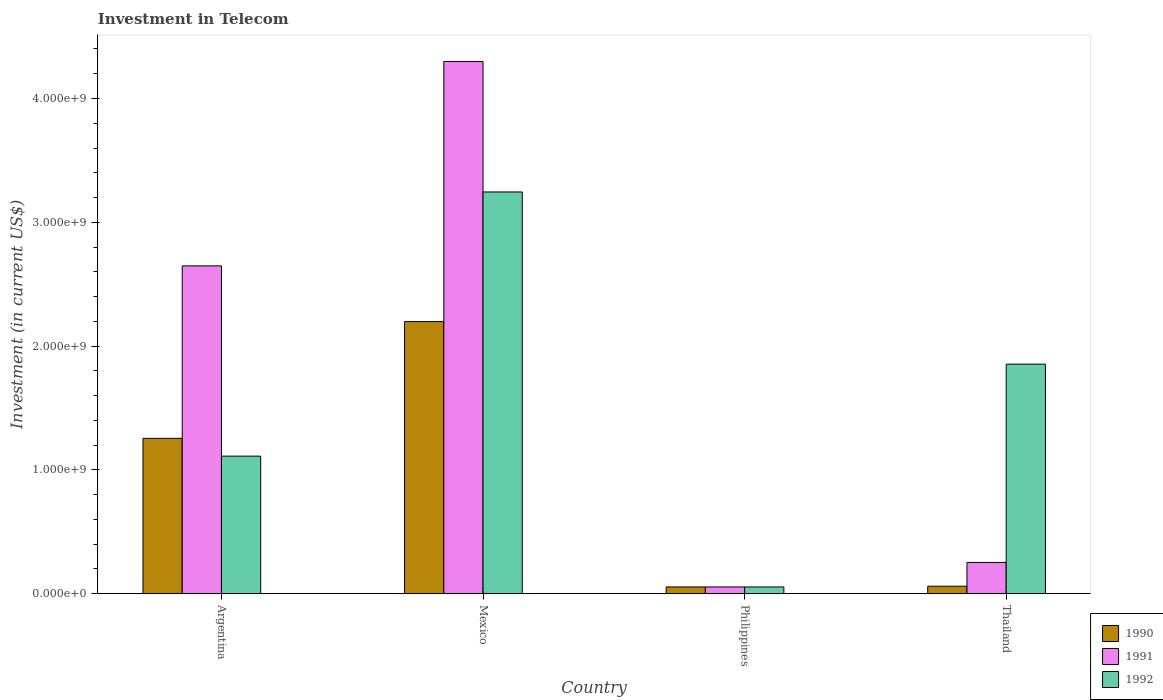How many bars are there on the 4th tick from the left?
Offer a very short reply. 3. How many bars are there on the 3rd tick from the right?
Offer a terse response. 3. What is the amount invested in telecom in 1990 in Philippines?
Offer a terse response. 5.42e+07. Across all countries, what is the maximum amount invested in telecom in 1992?
Offer a terse response. 3.24e+09. Across all countries, what is the minimum amount invested in telecom in 1992?
Give a very brief answer. 5.42e+07. What is the total amount invested in telecom in 1990 in the graph?
Keep it short and to the point. 3.57e+09. What is the difference between the amount invested in telecom in 1992 in Argentina and that in Philippines?
Ensure brevity in your answer.  1.06e+09. What is the difference between the amount invested in telecom in 1991 in Thailand and the amount invested in telecom in 1992 in Argentina?
Provide a short and direct response. -8.59e+08. What is the average amount invested in telecom in 1991 per country?
Give a very brief answer. 1.81e+09. What is the difference between the amount invested in telecom of/in 1991 and amount invested in telecom of/in 1990 in Mexico?
Provide a succinct answer. 2.10e+09. In how many countries, is the amount invested in telecom in 1991 greater than 2400000000 US$?
Your response must be concise. 2. What is the ratio of the amount invested in telecom in 1992 in Mexico to that in Philippines?
Ensure brevity in your answer.  59.87. Is the amount invested in telecom in 1992 in Mexico less than that in Philippines?
Give a very brief answer. No. What is the difference between the highest and the second highest amount invested in telecom in 1990?
Provide a short and direct response. 2.14e+09. What is the difference between the highest and the lowest amount invested in telecom in 1991?
Your answer should be very brief. 4.24e+09. What does the 2nd bar from the left in Thailand represents?
Make the answer very short. 1991. Is it the case that in every country, the sum of the amount invested in telecom in 1990 and amount invested in telecom in 1992 is greater than the amount invested in telecom in 1991?
Offer a terse response. No. How many bars are there?
Offer a very short reply. 12. Are all the bars in the graph horizontal?
Your answer should be compact. No. What is the difference between two consecutive major ticks on the Y-axis?
Keep it short and to the point. 1.00e+09. Are the values on the major ticks of Y-axis written in scientific E-notation?
Make the answer very short. Yes. Where does the legend appear in the graph?
Keep it short and to the point. Bottom right. How many legend labels are there?
Offer a very short reply. 3. What is the title of the graph?
Make the answer very short. Investment in Telecom. Does "2006" appear as one of the legend labels in the graph?
Give a very brief answer. No. What is the label or title of the X-axis?
Keep it short and to the point. Country. What is the label or title of the Y-axis?
Give a very brief answer. Investment (in current US$). What is the Investment (in current US$) in 1990 in Argentina?
Offer a terse response. 1.25e+09. What is the Investment (in current US$) of 1991 in Argentina?
Make the answer very short. 2.65e+09. What is the Investment (in current US$) of 1992 in Argentina?
Your answer should be compact. 1.11e+09. What is the Investment (in current US$) in 1990 in Mexico?
Give a very brief answer. 2.20e+09. What is the Investment (in current US$) in 1991 in Mexico?
Give a very brief answer. 4.30e+09. What is the Investment (in current US$) of 1992 in Mexico?
Offer a very short reply. 3.24e+09. What is the Investment (in current US$) in 1990 in Philippines?
Make the answer very short. 5.42e+07. What is the Investment (in current US$) of 1991 in Philippines?
Your response must be concise. 5.42e+07. What is the Investment (in current US$) in 1992 in Philippines?
Your answer should be compact. 5.42e+07. What is the Investment (in current US$) of 1990 in Thailand?
Your answer should be compact. 6.00e+07. What is the Investment (in current US$) in 1991 in Thailand?
Your answer should be very brief. 2.52e+08. What is the Investment (in current US$) in 1992 in Thailand?
Keep it short and to the point. 1.85e+09. Across all countries, what is the maximum Investment (in current US$) of 1990?
Keep it short and to the point. 2.20e+09. Across all countries, what is the maximum Investment (in current US$) of 1991?
Ensure brevity in your answer.  4.30e+09. Across all countries, what is the maximum Investment (in current US$) in 1992?
Keep it short and to the point. 3.24e+09. Across all countries, what is the minimum Investment (in current US$) in 1990?
Provide a succinct answer. 5.42e+07. Across all countries, what is the minimum Investment (in current US$) in 1991?
Your response must be concise. 5.42e+07. Across all countries, what is the minimum Investment (in current US$) of 1992?
Your answer should be very brief. 5.42e+07. What is the total Investment (in current US$) of 1990 in the graph?
Give a very brief answer. 3.57e+09. What is the total Investment (in current US$) in 1991 in the graph?
Your answer should be very brief. 7.25e+09. What is the total Investment (in current US$) in 1992 in the graph?
Your answer should be compact. 6.26e+09. What is the difference between the Investment (in current US$) of 1990 in Argentina and that in Mexico?
Make the answer very short. -9.43e+08. What is the difference between the Investment (in current US$) of 1991 in Argentina and that in Mexico?
Make the answer very short. -1.65e+09. What is the difference between the Investment (in current US$) of 1992 in Argentina and that in Mexico?
Keep it short and to the point. -2.13e+09. What is the difference between the Investment (in current US$) in 1990 in Argentina and that in Philippines?
Your answer should be compact. 1.20e+09. What is the difference between the Investment (in current US$) in 1991 in Argentina and that in Philippines?
Your answer should be compact. 2.59e+09. What is the difference between the Investment (in current US$) of 1992 in Argentina and that in Philippines?
Offer a very short reply. 1.06e+09. What is the difference between the Investment (in current US$) in 1990 in Argentina and that in Thailand?
Your response must be concise. 1.19e+09. What is the difference between the Investment (in current US$) of 1991 in Argentina and that in Thailand?
Ensure brevity in your answer.  2.40e+09. What is the difference between the Investment (in current US$) in 1992 in Argentina and that in Thailand?
Provide a short and direct response. -7.43e+08. What is the difference between the Investment (in current US$) in 1990 in Mexico and that in Philippines?
Give a very brief answer. 2.14e+09. What is the difference between the Investment (in current US$) in 1991 in Mexico and that in Philippines?
Offer a terse response. 4.24e+09. What is the difference between the Investment (in current US$) in 1992 in Mexico and that in Philippines?
Give a very brief answer. 3.19e+09. What is the difference between the Investment (in current US$) in 1990 in Mexico and that in Thailand?
Give a very brief answer. 2.14e+09. What is the difference between the Investment (in current US$) in 1991 in Mexico and that in Thailand?
Offer a terse response. 4.05e+09. What is the difference between the Investment (in current US$) of 1992 in Mexico and that in Thailand?
Give a very brief answer. 1.39e+09. What is the difference between the Investment (in current US$) in 1990 in Philippines and that in Thailand?
Your answer should be very brief. -5.80e+06. What is the difference between the Investment (in current US$) in 1991 in Philippines and that in Thailand?
Your answer should be compact. -1.98e+08. What is the difference between the Investment (in current US$) of 1992 in Philippines and that in Thailand?
Provide a succinct answer. -1.80e+09. What is the difference between the Investment (in current US$) of 1990 in Argentina and the Investment (in current US$) of 1991 in Mexico?
Give a very brief answer. -3.04e+09. What is the difference between the Investment (in current US$) in 1990 in Argentina and the Investment (in current US$) in 1992 in Mexico?
Offer a very short reply. -1.99e+09. What is the difference between the Investment (in current US$) in 1991 in Argentina and the Investment (in current US$) in 1992 in Mexico?
Your answer should be very brief. -5.97e+08. What is the difference between the Investment (in current US$) of 1990 in Argentina and the Investment (in current US$) of 1991 in Philippines?
Provide a short and direct response. 1.20e+09. What is the difference between the Investment (in current US$) of 1990 in Argentina and the Investment (in current US$) of 1992 in Philippines?
Provide a succinct answer. 1.20e+09. What is the difference between the Investment (in current US$) of 1991 in Argentina and the Investment (in current US$) of 1992 in Philippines?
Give a very brief answer. 2.59e+09. What is the difference between the Investment (in current US$) of 1990 in Argentina and the Investment (in current US$) of 1991 in Thailand?
Keep it short and to the point. 1.00e+09. What is the difference between the Investment (in current US$) of 1990 in Argentina and the Investment (in current US$) of 1992 in Thailand?
Ensure brevity in your answer.  -5.99e+08. What is the difference between the Investment (in current US$) of 1991 in Argentina and the Investment (in current US$) of 1992 in Thailand?
Your answer should be very brief. 7.94e+08. What is the difference between the Investment (in current US$) in 1990 in Mexico and the Investment (in current US$) in 1991 in Philippines?
Give a very brief answer. 2.14e+09. What is the difference between the Investment (in current US$) in 1990 in Mexico and the Investment (in current US$) in 1992 in Philippines?
Offer a terse response. 2.14e+09. What is the difference between the Investment (in current US$) in 1991 in Mexico and the Investment (in current US$) in 1992 in Philippines?
Your answer should be compact. 4.24e+09. What is the difference between the Investment (in current US$) in 1990 in Mexico and the Investment (in current US$) in 1991 in Thailand?
Give a very brief answer. 1.95e+09. What is the difference between the Investment (in current US$) in 1990 in Mexico and the Investment (in current US$) in 1992 in Thailand?
Offer a terse response. 3.44e+08. What is the difference between the Investment (in current US$) of 1991 in Mexico and the Investment (in current US$) of 1992 in Thailand?
Offer a very short reply. 2.44e+09. What is the difference between the Investment (in current US$) in 1990 in Philippines and the Investment (in current US$) in 1991 in Thailand?
Ensure brevity in your answer.  -1.98e+08. What is the difference between the Investment (in current US$) in 1990 in Philippines and the Investment (in current US$) in 1992 in Thailand?
Ensure brevity in your answer.  -1.80e+09. What is the difference between the Investment (in current US$) of 1991 in Philippines and the Investment (in current US$) of 1992 in Thailand?
Your answer should be compact. -1.80e+09. What is the average Investment (in current US$) in 1990 per country?
Offer a terse response. 8.92e+08. What is the average Investment (in current US$) in 1991 per country?
Ensure brevity in your answer.  1.81e+09. What is the average Investment (in current US$) in 1992 per country?
Provide a short and direct response. 1.57e+09. What is the difference between the Investment (in current US$) in 1990 and Investment (in current US$) in 1991 in Argentina?
Offer a very short reply. -1.39e+09. What is the difference between the Investment (in current US$) in 1990 and Investment (in current US$) in 1992 in Argentina?
Provide a short and direct response. 1.44e+08. What is the difference between the Investment (in current US$) of 1991 and Investment (in current US$) of 1992 in Argentina?
Provide a succinct answer. 1.54e+09. What is the difference between the Investment (in current US$) in 1990 and Investment (in current US$) in 1991 in Mexico?
Ensure brevity in your answer.  -2.10e+09. What is the difference between the Investment (in current US$) in 1990 and Investment (in current US$) in 1992 in Mexico?
Make the answer very short. -1.05e+09. What is the difference between the Investment (in current US$) of 1991 and Investment (in current US$) of 1992 in Mexico?
Make the answer very short. 1.05e+09. What is the difference between the Investment (in current US$) of 1990 and Investment (in current US$) of 1992 in Philippines?
Keep it short and to the point. 0. What is the difference between the Investment (in current US$) in 1991 and Investment (in current US$) in 1992 in Philippines?
Offer a very short reply. 0. What is the difference between the Investment (in current US$) of 1990 and Investment (in current US$) of 1991 in Thailand?
Your answer should be compact. -1.92e+08. What is the difference between the Investment (in current US$) in 1990 and Investment (in current US$) in 1992 in Thailand?
Ensure brevity in your answer.  -1.79e+09. What is the difference between the Investment (in current US$) of 1991 and Investment (in current US$) of 1992 in Thailand?
Give a very brief answer. -1.60e+09. What is the ratio of the Investment (in current US$) of 1990 in Argentina to that in Mexico?
Offer a terse response. 0.57. What is the ratio of the Investment (in current US$) in 1991 in Argentina to that in Mexico?
Offer a very short reply. 0.62. What is the ratio of the Investment (in current US$) in 1992 in Argentina to that in Mexico?
Provide a short and direct response. 0.34. What is the ratio of the Investment (in current US$) in 1990 in Argentina to that in Philippines?
Your response must be concise. 23.15. What is the ratio of the Investment (in current US$) of 1991 in Argentina to that in Philippines?
Keep it short and to the point. 48.86. What is the ratio of the Investment (in current US$) in 1992 in Argentina to that in Philippines?
Give a very brief answer. 20.5. What is the ratio of the Investment (in current US$) of 1990 in Argentina to that in Thailand?
Keep it short and to the point. 20.91. What is the ratio of the Investment (in current US$) in 1991 in Argentina to that in Thailand?
Make the answer very short. 10.51. What is the ratio of the Investment (in current US$) in 1992 in Argentina to that in Thailand?
Your answer should be very brief. 0.6. What is the ratio of the Investment (in current US$) of 1990 in Mexico to that in Philippines?
Provide a short and direct response. 40.55. What is the ratio of the Investment (in current US$) in 1991 in Mexico to that in Philippines?
Offer a terse response. 79.32. What is the ratio of the Investment (in current US$) of 1992 in Mexico to that in Philippines?
Your answer should be very brief. 59.87. What is the ratio of the Investment (in current US$) of 1990 in Mexico to that in Thailand?
Keep it short and to the point. 36.63. What is the ratio of the Investment (in current US$) of 1991 in Mexico to that in Thailand?
Make the answer very short. 17.06. What is the ratio of the Investment (in current US$) of 1992 in Mexico to that in Thailand?
Your answer should be very brief. 1.75. What is the ratio of the Investment (in current US$) of 1990 in Philippines to that in Thailand?
Your answer should be compact. 0.9. What is the ratio of the Investment (in current US$) of 1991 in Philippines to that in Thailand?
Provide a short and direct response. 0.22. What is the ratio of the Investment (in current US$) of 1992 in Philippines to that in Thailand?
Keep it short and to the point. 0.03. What is the difference between the highest and the second highest Investment (in current US$) in 1990?
Offer a very short reply. 9.43e+08. What is the difference between the highest and the second highest Investment (in current US$) in 1991?
Give a very brief answer. 1.65e+09. What is the difference between the highest and the second highest Investment (in current US$) in 1992?
Give a very brief answer. 1.39e+09. What is the difference between the highest and the lowest Investment (in current US$) of 1990?
Your response must be concise. 2.14e+09. What is the difference between the highest and the lowest Investment (in current US$) of 1991?
Provide a succinct answer. 4.24e+09. What is the difference between the highest and the lowest Investment (in current US$) in 1992?
Give a very brief answer. 3.19e+09. 